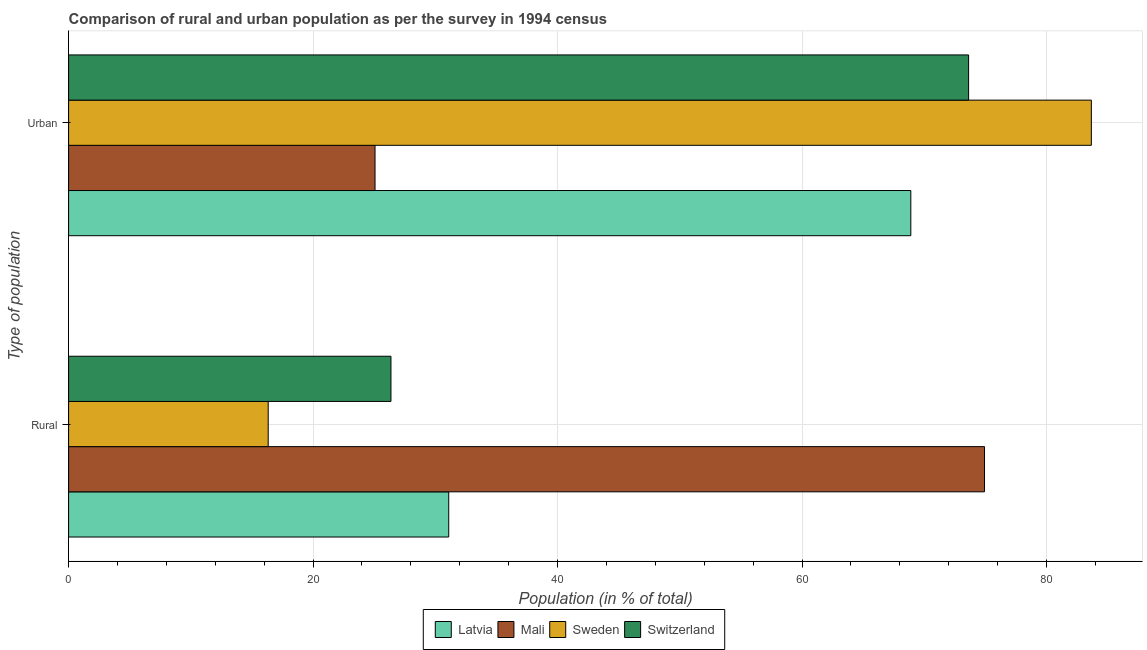How many groups of bars are there?
Your response must be concise. 2. Are the number of bars per tick equal to the number of legend labels?
Ensure brevity in your answer.  Yes. How many bars are there on the 1st tick from the top?
Your answer should be compact. 4. How many bars are there on the 1st tick from the bottom?
Give a very brief answer. 4. What is the label of the 1st group of bars from the top?
Your answer should be compact. Urban. What is the rural population in Switzerland?
Provide a short and direct response. 26.37. Across all countries, what is the maximum urban population?
Your response must be concise. 83.67. Across all countries, what is the minimum urban population?
Provide a short and direct response. 25.07. In which country was the urban population minimum?
Give a very brief answer. Mali. What is the total urban population in the graph?
Ensure brevity in your answer.  251.27. What is the difference between the rural population in Mali and that in Switzerland?
Your answer should be very brief. 48.56. What is the difference between the urban population in Mali and the rural population in Switzerland?
Make the answer very short. -1.3. What is the average urban population per country?
Your answer should be very brief. 62.82. What is the difference between the urban population and rural population in Mali?
Your answer should be compact. -49.86. What is the ratio of the rural population in Sweden to that in Mali?
Make the answer very short. 0.22. In how many countries, is the urban population greater than the average urban population taken over all countries?
Your response must be concise. 3. What does the 4th bar from the top in Rural represents?
Your answer should be compact. Latvia. What does the 2nd bar from the bottom in Urban represents?
Your answer should be compact. Mali. Does the graph contain grids?
Your response must be concise. Yes. What is the title of the graph?
Your response must be concise. Comparison of rural and urban population as per the survey in 1994 census. Does "Latin America(developing only)" appear as one of the legend labels in the graph?
Keep it short and to the point. No. What is the label or title of the X-axis?
Your response must be concise. Population (in % of total). What is the label or title of the Y-axis?
Offer a terse response. Type of population. What is the Population (in % of total) in Latvia in Rural?
Your answer should be very brief. 31.1. What is the Population (in % of total) of Mali in Rural?
Make the answer very short. 74.93. What is the Population (in % of total) in Sweden in Rural?
Give a very brief answer. 16.33. What is the Population (in % of total) of Switzerland in Rural?
Provide a succinct answer. 26.37. What is the Population (in % of total) of Latvia in Urban?
Provide a succinct answer. 68.9. What is the Population (in % of total) of Mali in Urban?
Provide a succinct answer. 25.07. What is the Population (in % of total) in Sweden in Urban?
Ensure brevity in your answer.  83.67. What is the Population (in % of total) of Switzerland in Urban?
Your answer should be compact. 73.63. Across all Type of population, what is the maximum Population (in % of total) in Latvia?
Offer a very short reply. 68.9. Across all Type of population, what is the maximum Population (in % of total) in Mali?
Make the answer very short. 74.93. Across all Type of population, what is the maximum Population (in % of total) in Sweden?
Your response must be concise. 83.67. Across all Type of population, what is the maximum Population (in % of total) in Switzerland?
Ensure brevity in your answer.  73.63. Across all Type of population, what is the minimum Population (in % of total) of Latvia?
Give a very brief answer. 31.1. Across all Type of population, what is the minimum Population (in % of total) in Mali?
Offer a terse response. 25.07. Across all Type of population, what is the minimum Population (in % of total) in Sweden?
Offer a very short reply. 16.33. Across all Type of population, what is the minimum Population (in % of total) of Switzerland?
Offer a very short reply. 26.37. What is the total Population (in % of total) of Mali in the graph?
Offer a terse response. 100. What is the difference between the Population (in % of total) of Latvia in Rural and that in Urban?
Keep it short and to the point. -37.8. What is the difference between the Population (in % of total) of Mali in Rural and that in Urban?
Make the answer very short. 49.86. What is the difference between the Population (in % of total) of Sweden in Rural and that in Urban?
Provide a short and direct response. -67.34. What is the difference between the Population (in % of total) of Switzerland in Rural and that in Urban?
Provide a short and direct response. -47.26. What is the difference between the Population (in % of total) of Latvia in Rural and the Population (in % of total) of Mali in Urban?
Give a very brief answer. 6.03. What is the difference between the Population (in % of total) in Latvia in Rural and the Population (in % of total) in Sweden in Urban?
Provide a succinct answer. -52.57. What is the difference between the Population (in % of total) in Latvia in Rural and the Population (in % of total) in Switzerland in Urban?
Offer a terse response. -42.53. What is the difference between the Population (in % of total) in Mali in Rural and the Population (in % of total) in Sweden in Urban?
Your answer should be compact. -8.74. What is the difference between the Population (in % of total) in Mali in Rural and the Population (in % of total) in Switzerland in Urban?
Your response must be concise. 1.3. What is the difference between the Population (in % of total) of Sweden in Rural and the Population (in % of total) of Switzerland in Urban?
Provide a short and direct response. -57.3. What is the average Population (in % of total) in Latvia per Type of population?
Ensure brevity in your answer.  50. What is the average Population (in % of total) in Mali per Type of population?
Ensure brevity in your answer.  50. What is the average Population (in % of total) in Sweden per Type of population?
Your response must be concise. 50. What is the average Population (in % of total) in Switzerland per Type of population?
Your answer should be very brief. 50. What is the difference between the Population (in % of total) of Latvia and Population (in % of total) of Mali in Rural?
Provide a short and direct response. -43.83. What is the difference between the Population (in % of total) in Latvia and Population (in % of total) in Sweden in Rural?
Keep it short and to the point. 14.77. What is the difference between the Population (in % of total) of Latvia and Population (in % of total) of Switzerland in Rural?
Provide a short and direct response. 4.73. What is the difference between the Population (in % of total) of Mali and Population (in % of total) of Sweden in Rural?
Ensure brevity in your answer.  58.6. What is the difference between the Population (in % of total) of Mali and Population (in % of total) of Switzerland in Rural?
Your response must be concise. 48.56. What is the difference between the Population (in % of total) of Sweden and Population (in % of total) of Switzerland in Rural?
Offer a terse response. -10.04. What is the difference between the Population (in % of total) of Latvia and Population (in % of total) of Mali in Urban?
Offer a terse response. 43.83. What is the difference between the Population (in % of total) of Latvia and Population (in % of total) of Sweden in Urban?
Your response must be concise. -14.77. What is the difference between the Population (in % of total) of Latvia and Population (in % of total) of Switzerland in Urban?
Your answer should be very brief. -4.73. What is the difference between the Population (in % of total) in Mali and Population (in % of total) in Sweden in Urban?
Your response must be concise. -58.6. What is the difference between the Population (in % of total) in Mali and Population (in % of total) in Switzerland in Urban?
Offer a terse response. -48.56. What is the difference between the Population (in % of total) in Sweden and Population (in % of total) in Switzerland in Urban?
Give a very brief answer. 10.04. What is the ratio of the Population (in % of total) of Latvia in Rural to that in Urban?
Make the answer very short. 0.45. What is the ratio of the Population (in % of total) in Mali in Rural to that in Urban?
Provide a short and direct response. 2.99. What is the ratio of the Population (in % of total) of Sweden in Rural to that in Urban?
Offer a very short reply. 0.2. What is the ratio of the Population (in % of total) of Switzerland in Rural to that in Urban?
Offer a very short reply. 0.36. What is the difference between the highest and the second highest Population (in % of total) of Latvia?
Provide a succinct answer. 37.8. What is the difference between the highest and the second highest Population (in % of total) of Mali?
Provide a succinct answer. 49.86. What is the difference between the highest and the second highest Population (in % of total) in Sweden?
Give a very brief answer. 67.34. What is the difference between the highest and the second highest Population (in % of total) of Switzerland?
Your answer should be compact. 47.26. What is the difference between the highest and the lowest Population (in % of total) in Latvia?
Your answer should be very brief. 37.8. What is the difference between the highest and the lowest Population (in % of total) in Mali?
Offer a very short reply. 49.86. What is the difference between the highest and the lowest Population (in % of total) in Sweden?
Make the answer very short. 67.34. What is the difference between the highest and the lowest Population (in % of total) of Switzerland?
Your answer should be compact. 47.26. 